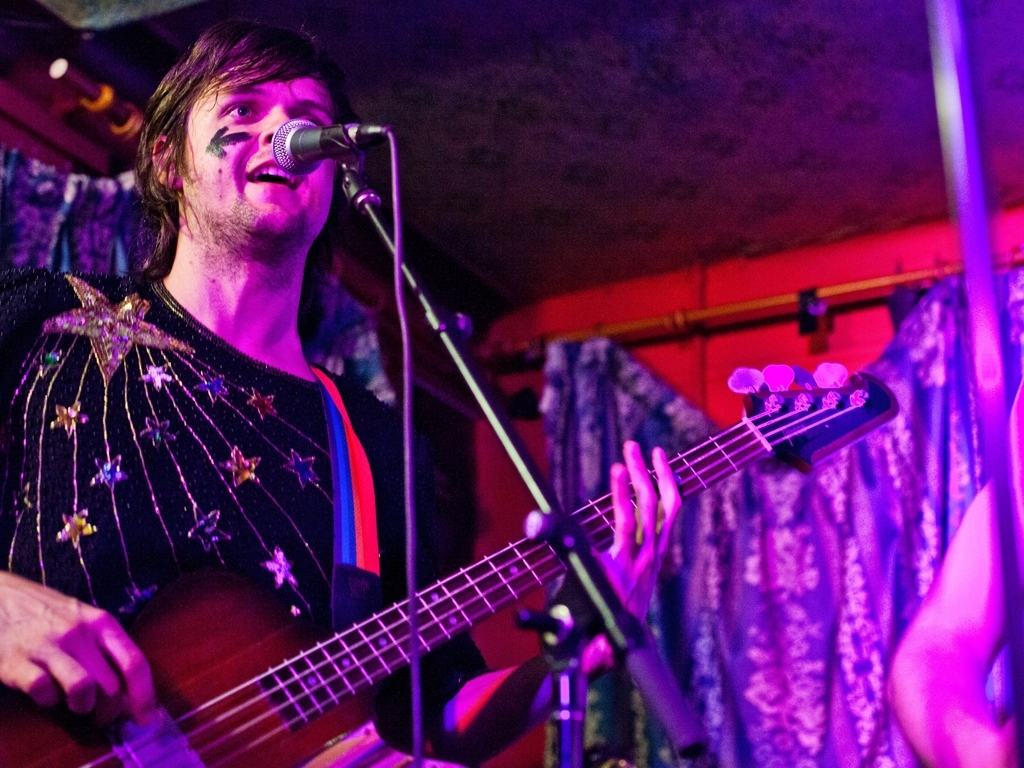What type of emotions does the musician's expression convey to the audience? The musician's expression is one of concentration and passion. His slightly furrowed brow and the way his lips are pressed against the microphone suggest a deep connection to the music he's playing. This intensity likely resonates with the audience, creating an emotional bond through the performance. 